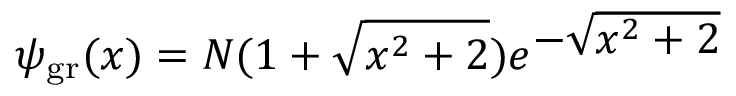<formula> <loc_0><loc_0><loc_500><loc_500>\psi _ { g r } ( x ) = N ( 1 + \sqrt { x ^ { 2 } + 2 } ) e ^ { - \sqrt { x ^ { 2 } + 2 } }</formula> 